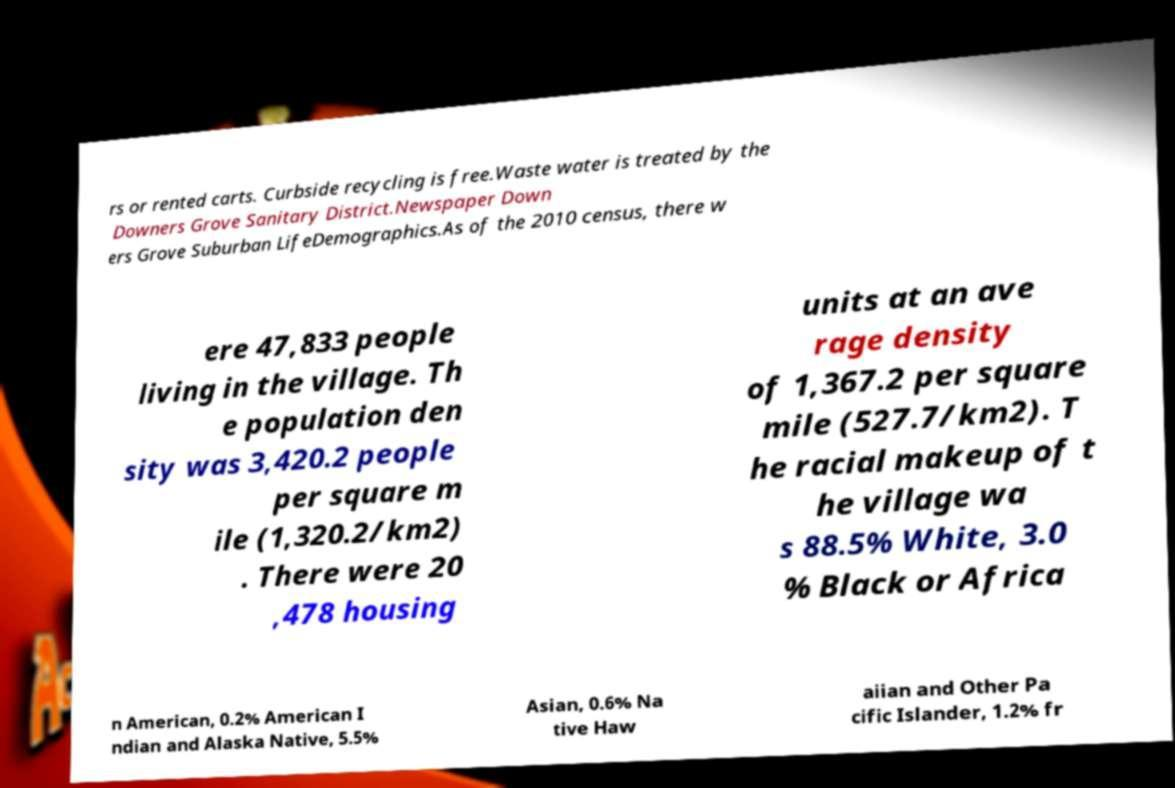Please read and relay the text visible in this image. What does it say? rs or rented carts. Curbside recycling is free.Waste water is treated by the Downers Grove Sanitary District.Newspaper Down ers Grove Suburban LifeDemographics.As of the 2010 census, there w ere 47,833 people living in the village. Th e population den sity was 3,420.2 people per square m ile (1,320.2/km2) . There were 20 ,478 housing units at an ave rage density of 1,367.2 per square mile (527.7/km2). T he racial makeup of t he village wa s 88.5% White, 3.0 % Black or Africa n American, 0.2% American I ndian and Alaska Native, 5.5% Asian, 0.6% Na tive Haw aiian and Other Pa cific Islander, 1.2% fr 